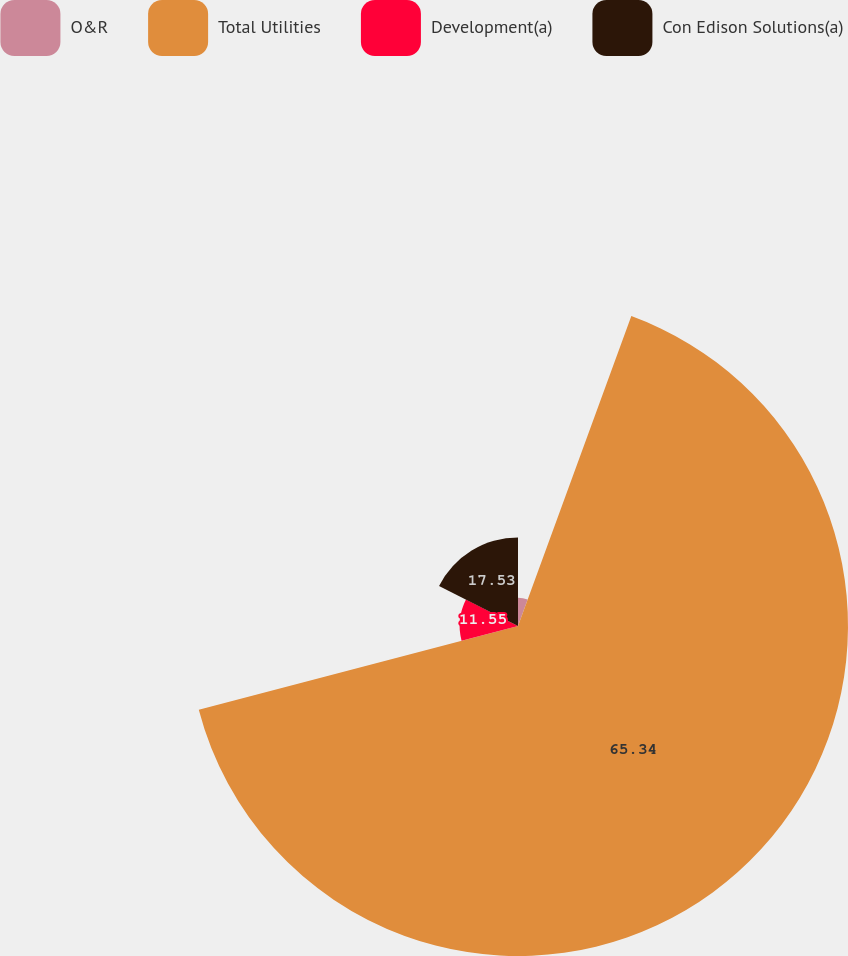<chart> <loc_0><loc_0><loc_500><loc_500><pie_chart><fcel>O&R<fcel>Total Utilities<fcel>Development(a)<fcel>Con Edison Solutions(a)<nl><fcel>5.58%<fcel>65.34%<fcel>11.55%<fcel>17.53%<nl></chart> 